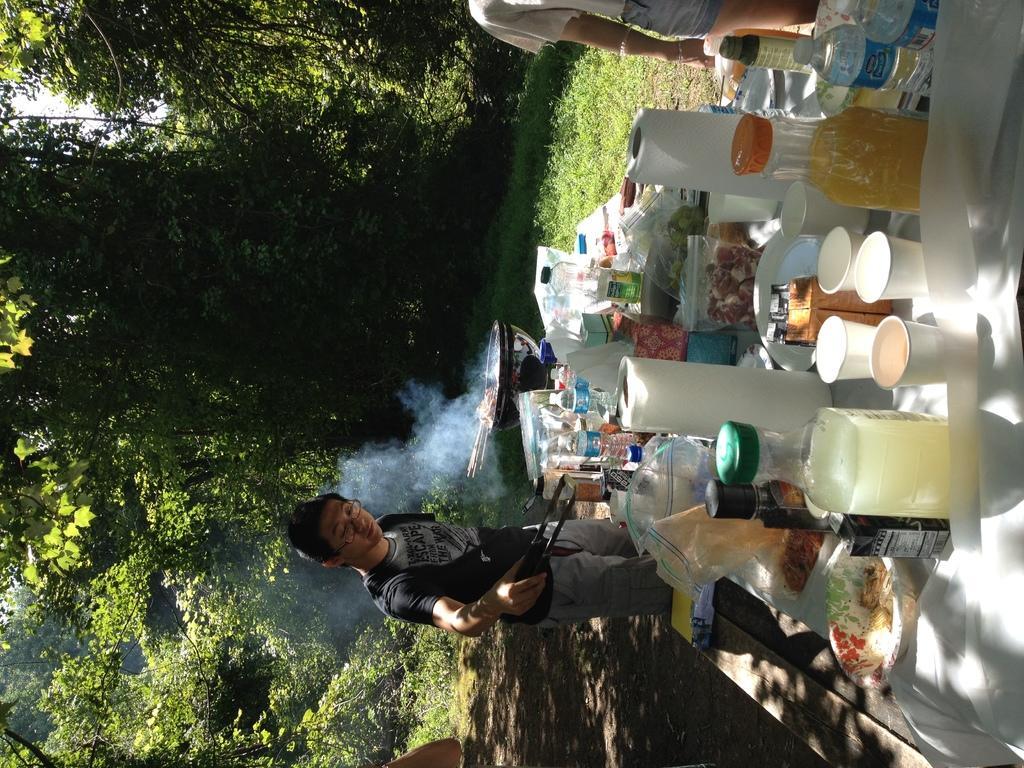Describe this image in one or two sentences. In this image there is a table and a bench. On the table there are bottles, glasses, tissues, packets and many other items. There is a person wearing specs. And he is holding a tongs. There is a bowl. Also there is another person. On the ground there is grass. There are trees. Near to the bowl there's smoke. 